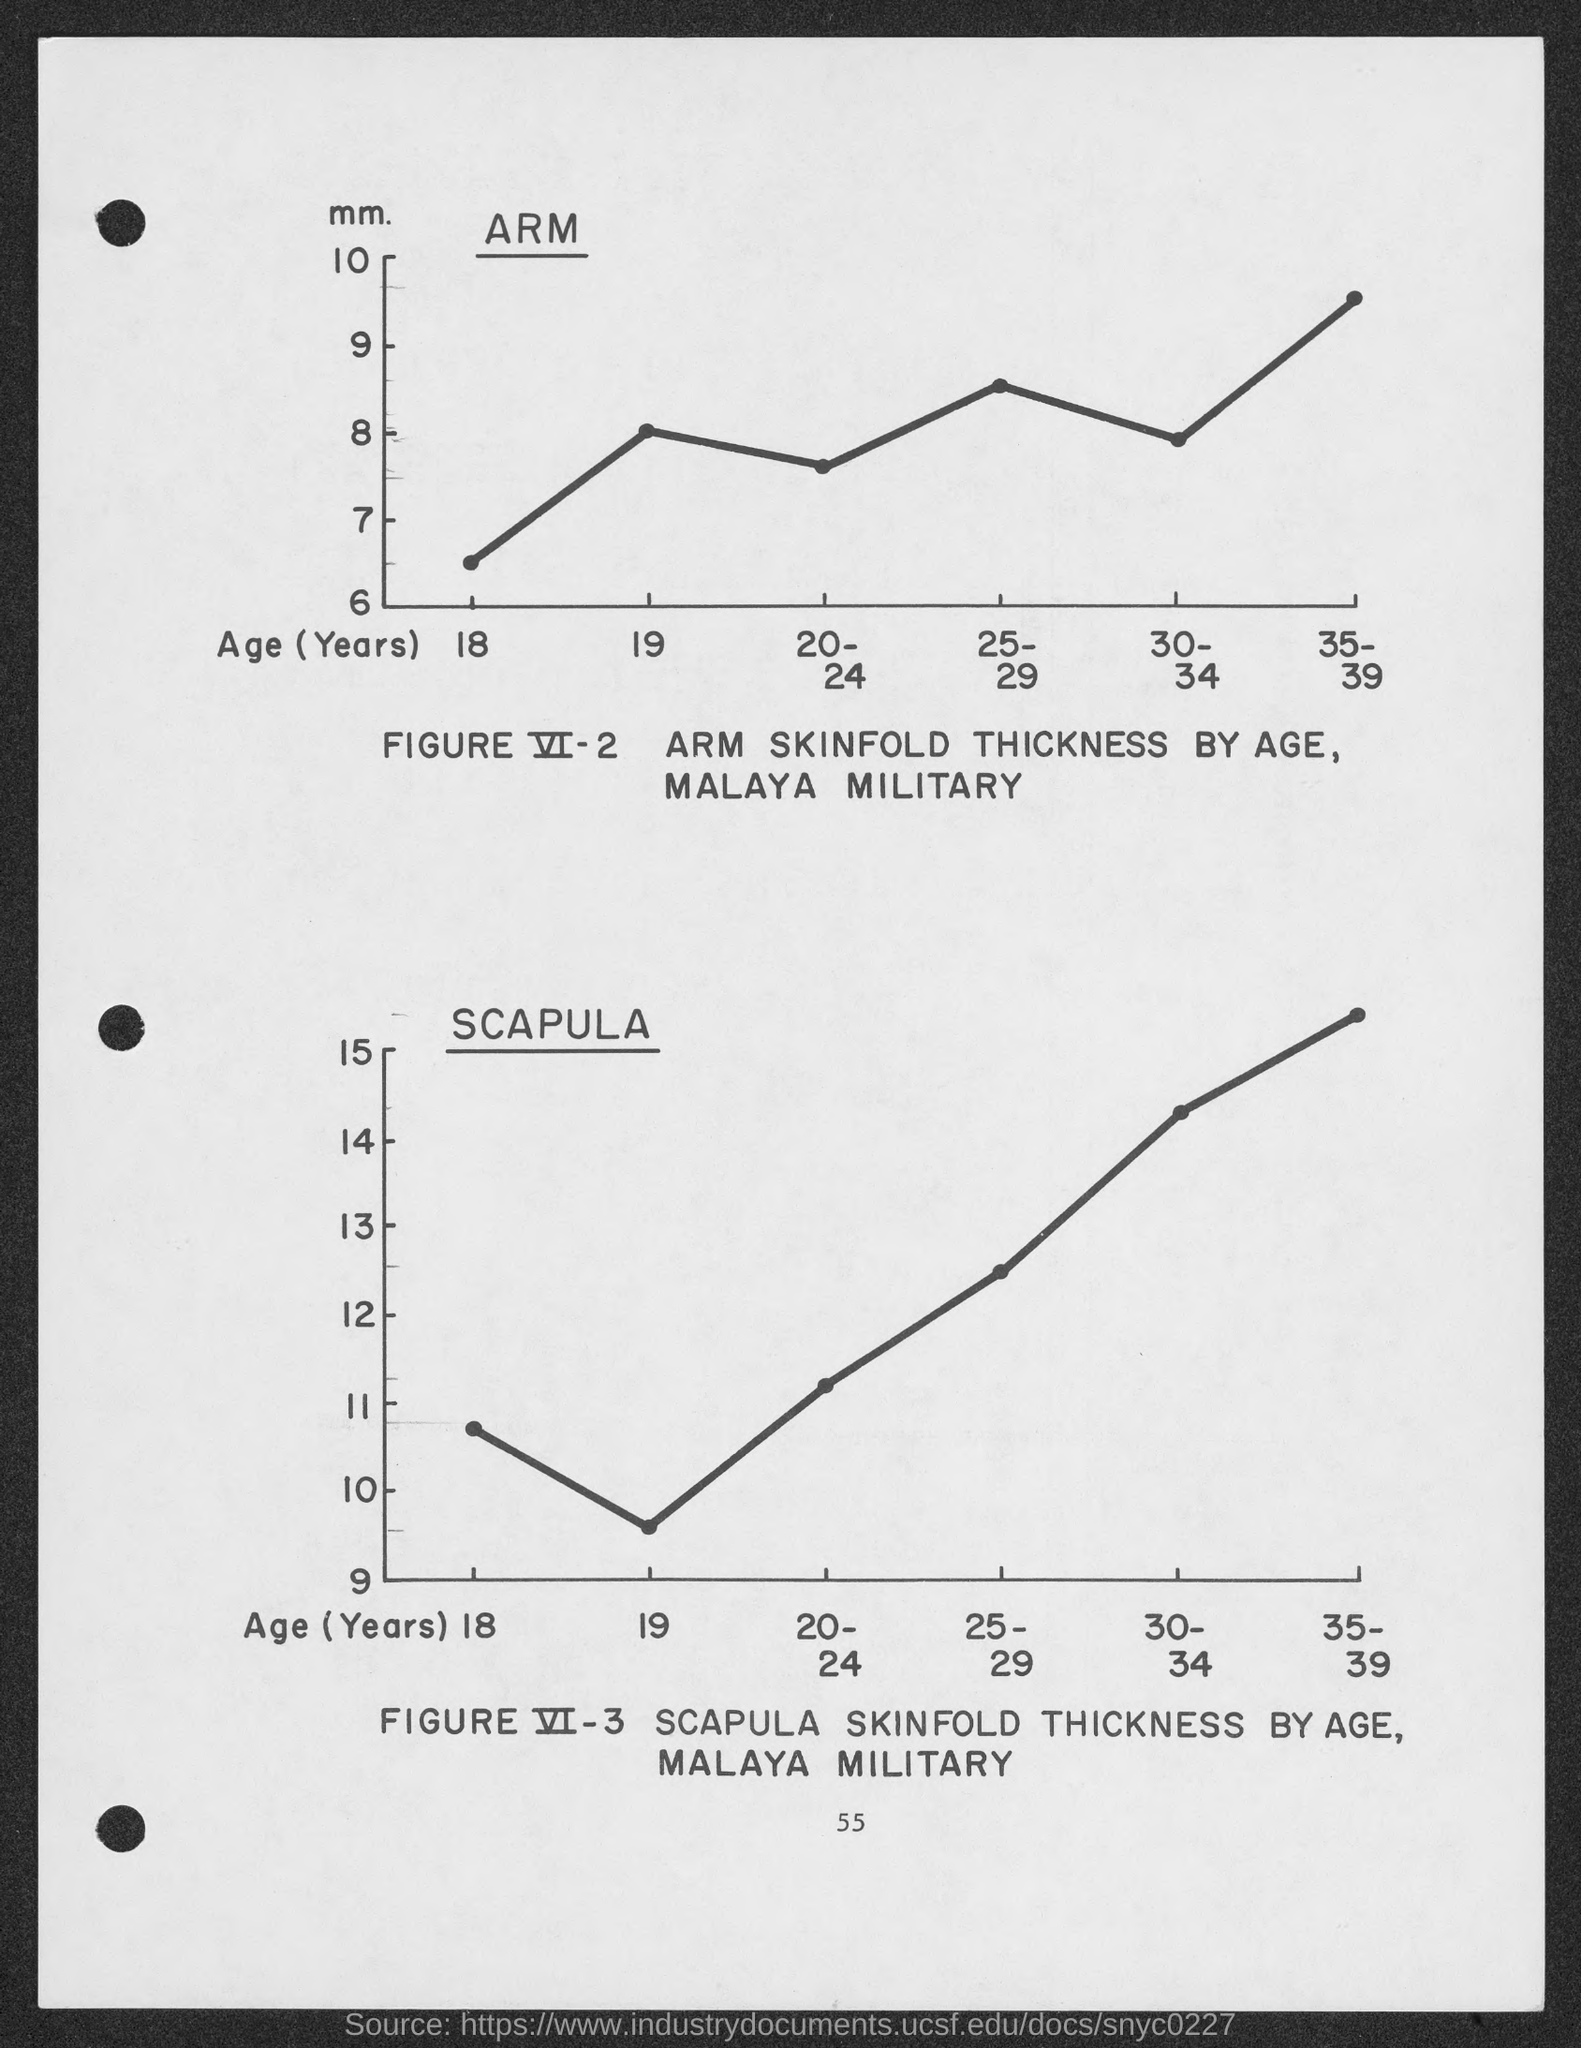Indicate a few pertinent items in this graphic. The unit on the Y-axis of the graph in Figure VI-2 is millimeters. Age (years) is the variable on the x-axis of FIGURE VI-3. 